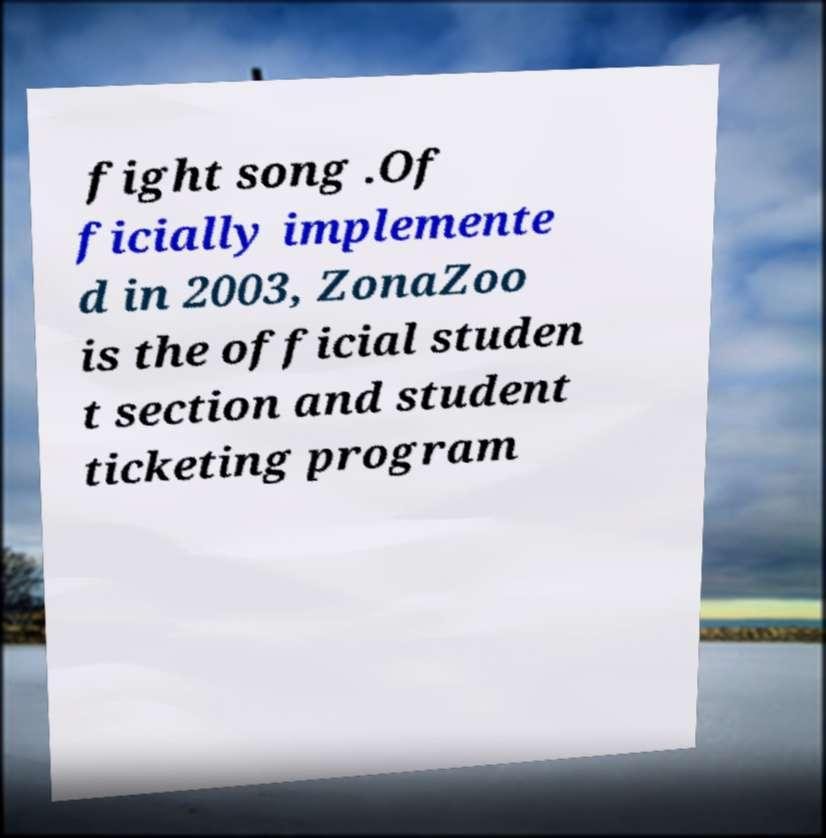Please read and relay the text visible in this image. What does it say? fight song .Of ficially implemente d in 2003, ZonaZoo is the official studen t section and student ticketing program 